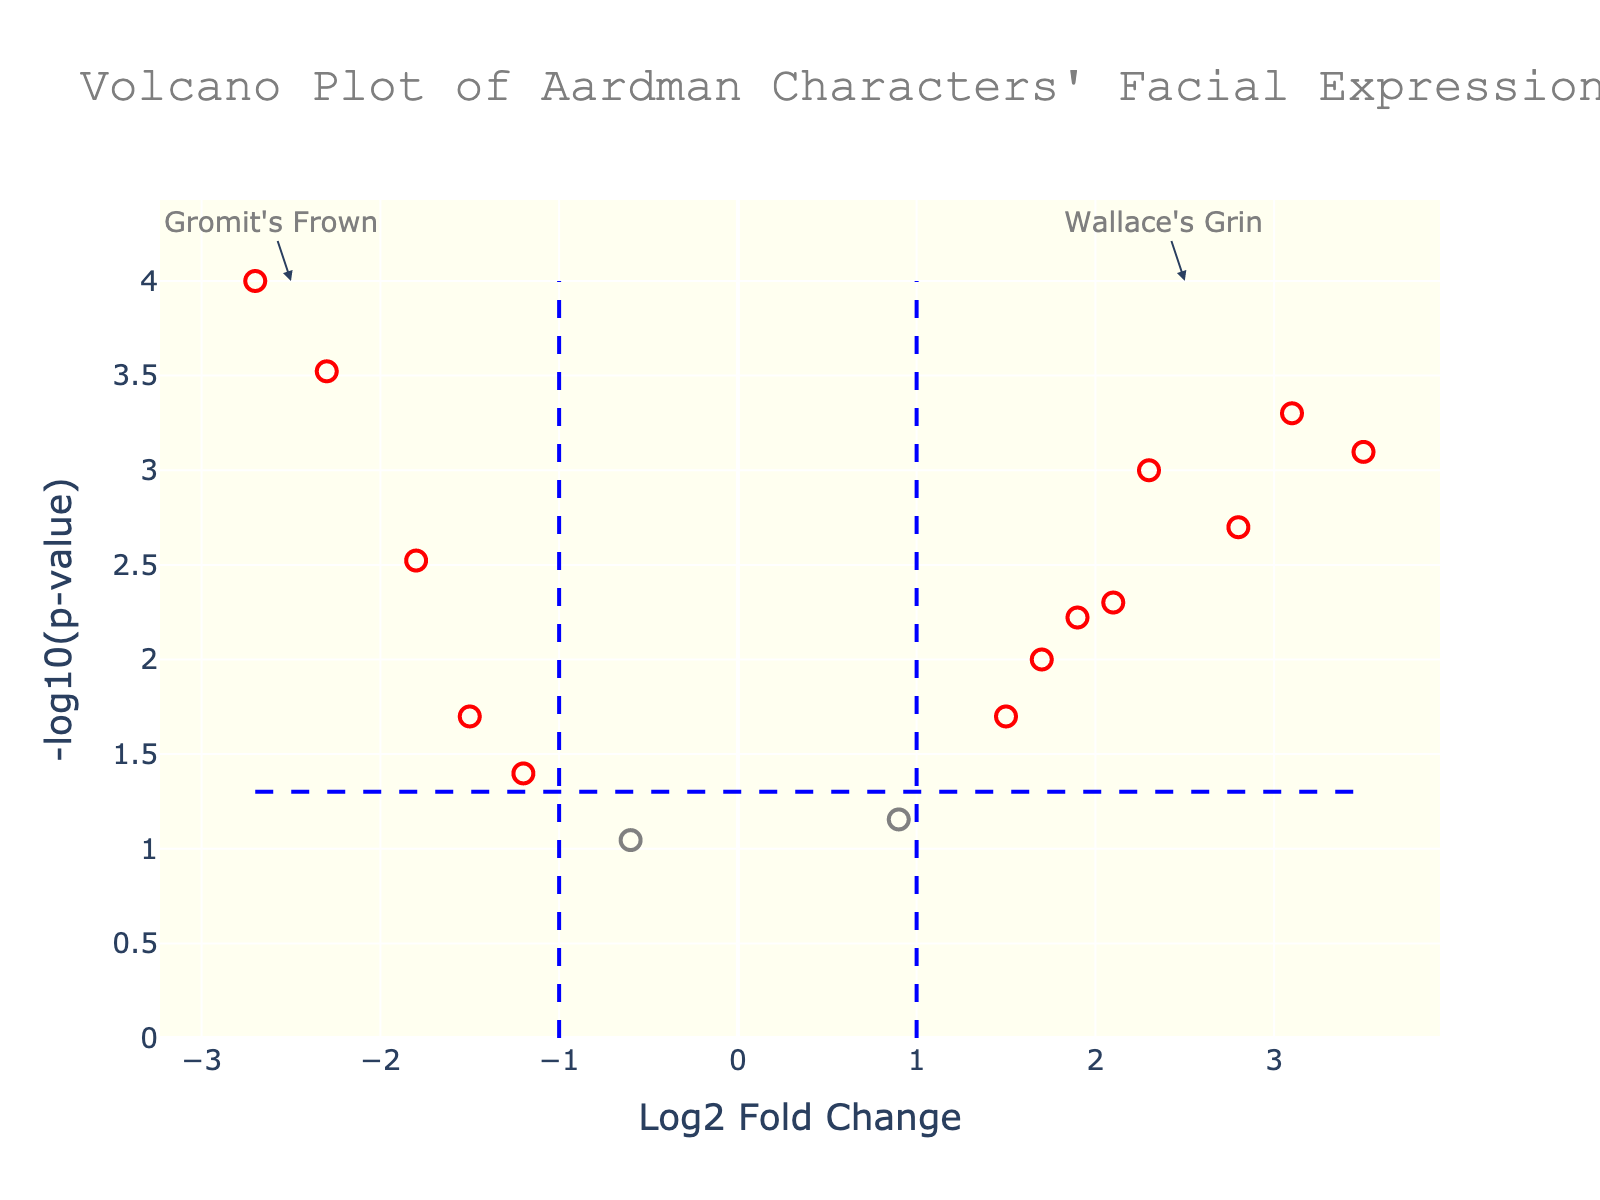What's the title of the plot? Look at the top of the plot where the title is located. It reads "Volcano Plot of Aardman Characters' Facial Expressions."
Answer: Volcano Plot of Aardman Characters' Facial Expressions How many genes are colored red in the plot? Red genes are those with absolute Log2 Fold Change > 1 and PValue < 0.05. By counting the red points, the figure has 9 red points.
Answer: 9 What's the -log10(p-value) for the gene 'GRIN3'? Locate the data point for the gene 'GRIN3.' Its p-value is 0.0005. The -log10(p-value) is calculated as -log10(0.0005) ≈ 3.3.
Answer: 3.3 Which gene has the highest Log2 Fold Change? Look for the data point with the highest x-axis value. The gene 'LIPS10' has the highest Log2 Fold Change of 3.5.
Answer: LIPS10 Which annotation marks Wallace's Grin? The annotation for Wallace's Grin features a text "Wallace's Grin" and points to an x-axis value around 2.5, in the higher -log10(p-value) range.
Answer: Wallace's Grin Name one gene with a negative Log2 Fold Change and significant p-value. A gene with a negative Log2 Fold Change and p-value < 0.05 would be colored red and have a negative x-axis value. 'CLAY5' has Log2 Fold Change -2.7 and p-value 0.0001.
Answer: CLAY5 What's the -log10(p-value) threshold line? The threshold line is drawn at -log10(0.05). Calculate -log10(0.05) which is approximately 1.3.
Answer: 1.3 What are the x and y values of the annotation "Gromit's Frown”? The annotation "Gromit's Frown" is placed at x around -2.5 and the highest y-axis value. By observing the lines and location, we confirm this.
Answer: x = -2.5, y = highest Which gene has the lowest -log10(p-value) among those with a significant Fold Change? To identify this, find the lowest y-value among red points. 'CHIN11' has a p-value of 0.09, corresponding to -log10(0.09) ≈ 1.05, the lowest value among red points.
Answer: CHIN11 